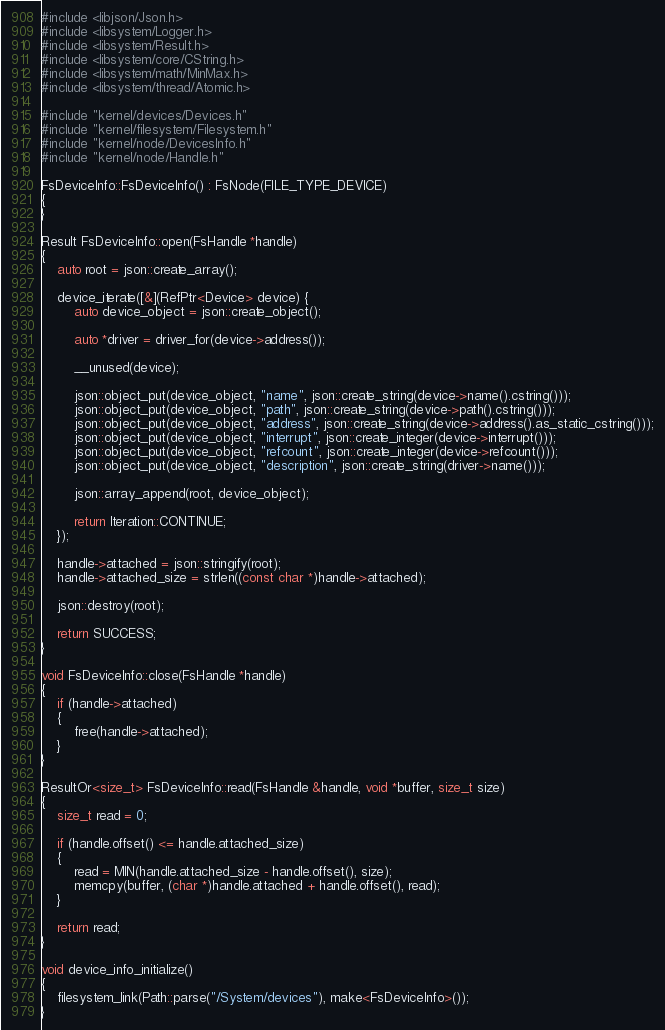Convert code to text. <code><loc_0><loc_0><loc_500><loc_500><_C++_>
#include <libjson/Json.h>
#include <libsystem/Logger.h>
#include <libsystem/Result.h>
#include <libsystem/core/CString.h>
#include <libsystem/math/MinMax.h>
#include <libsystem/thread/Atomic.h>

#include "kernel/devices/Devices.h"
#include "kernel/filesystem/Filesystem.h"
#include "kernel/node/DevicesInfo.h"
#include "kernel/node/Handle.h"

FsDeviceInfo::FsDeviceInfo() : FsNode(FILE_TYPE_DEVICE)
{
}

Result FsDeviceInfo::open(FsHandle *handle)
{
    auto root = json::create_array();

    device_iterate([&](RefPtr<Device> device) {
        auto device_object = json::create_object();

        auto *driver = driver_for(device->address());

        __unused(device);

        json::object_put(device_object, "name", json::create_string(device->name().cstring()));
        json::object_put(device_object, "path", json::create_string(device->path().cstring()));
        json::object_put(device_object, "address", json::create_string(device->address().as_static_cstring()));
        json::object_put(device_object, "interrupt", json::create_integer(device->interrupt()));
        json::object_put(device_object, "refcount", json::create_integer(device->refcount()));
        json::object_put(device_object, "description", json::create_string(driver->name()));

        json::array_append(root, device_object);

        return Iteration::CONTINUE;
    });

    handle->attached = json::stringify(root);
    handle->attached_size = strlen((const char *)handle->attached);

    json::destroy(root);

    return SUCCESS;
}

void FsDeviceInfo::close(FsHandle *handle)
{
    if (handle->attached)
    {
        free(handle->attached);
    }
}

ResultOr<size_t> FsDeviceInfo::read(FsHandle &handle, void *buffer, size_t size)
{
    size_t read = 0;

    if (handle.offset() <= handle.attached_size)
    {
        read = MIN(handle.attached_size - handle.offset(), size);
        memcpy(buffer, (char *)handle.attached + handle.offset(), read);
    }

    return read;
}

void device_info_initialize()
{
    filesystem_link(Path::parse("/System/devices"), make<FsDeviceInfo>());
}
</code> 